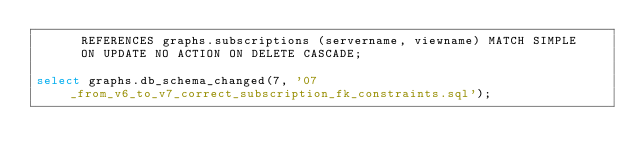Convert code to text. <code><loc_0><loc_0><loc_500><loc_500><_SQL_>      REFERENCES graphs.subscriptions (servername, viewname) MATCH SIMPLE
      ON UPDATE NO ACTION ON DELETE CASCADE;

select graphs.db_schema_changed(7, '07_from_v6_to_v7_correct_subscription_fk_constraints.sql');</code> 